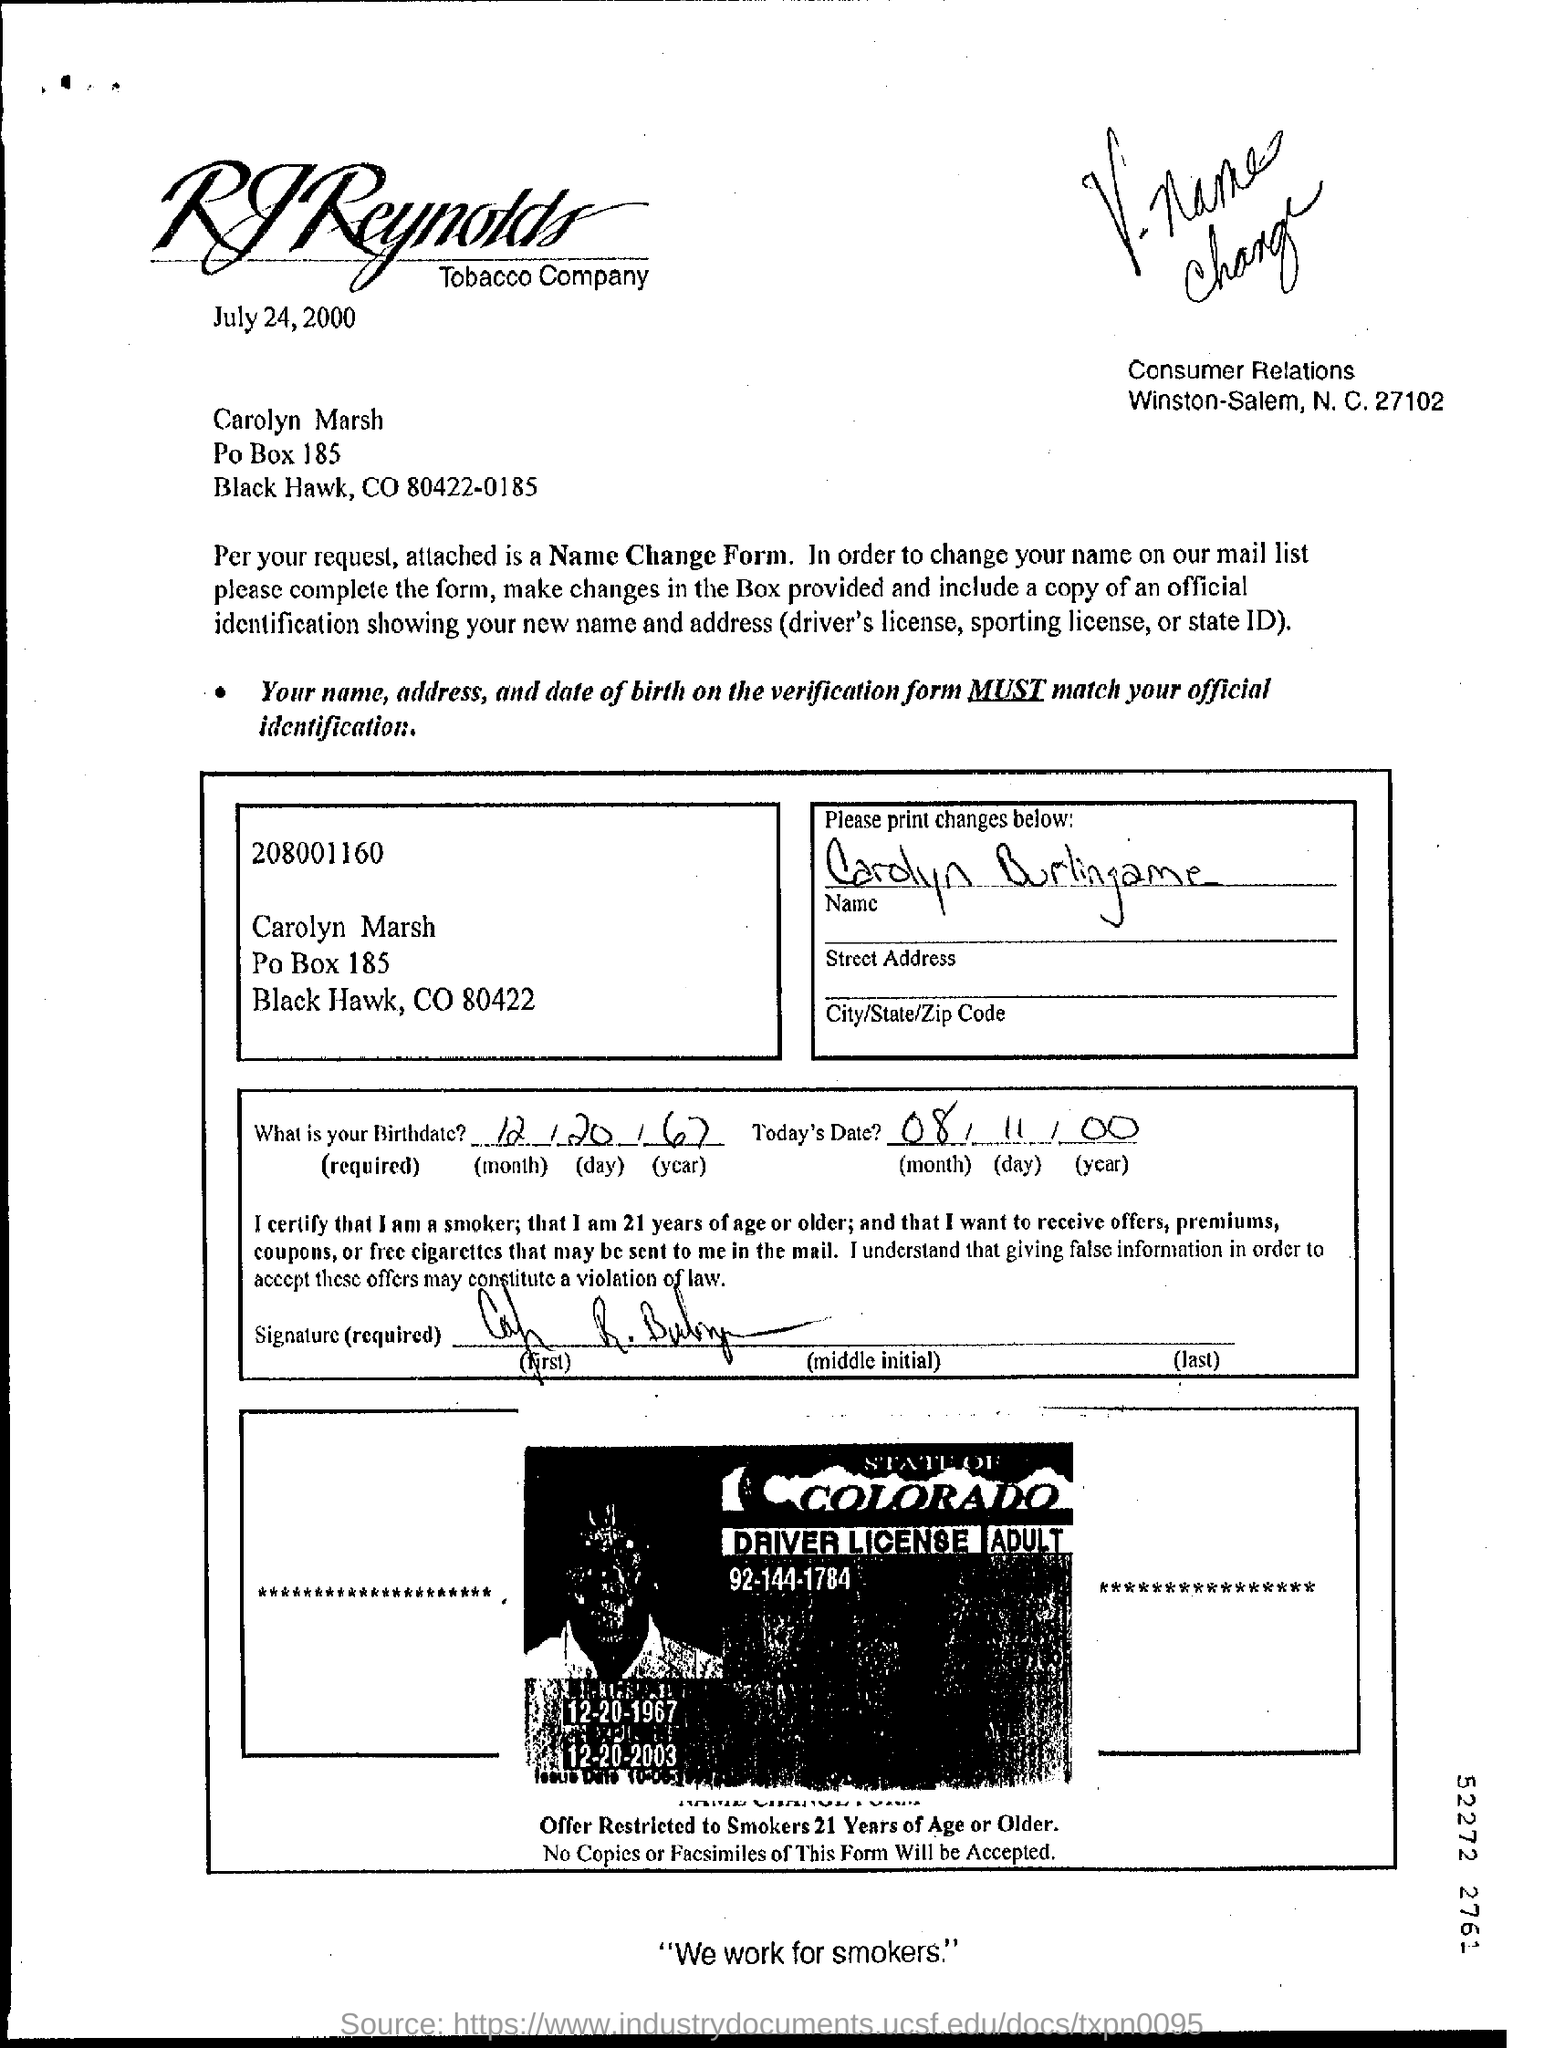Who is the letter addressed to?
Ensure brevity in your answer.  Carolyn Marsh. What is the letter dated?
Your response must be concise. July 24, 2000. 